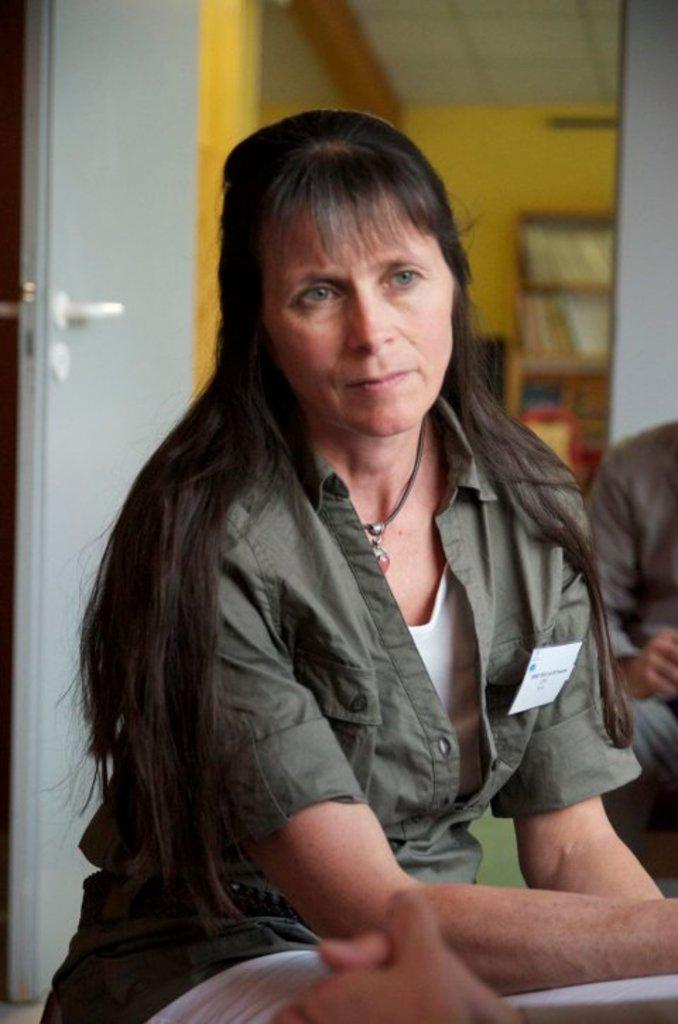Who or what is present in the image? There are people in the image. What can be seen in the background of the image? There are books in the background of the image. How are the books arranged in the image? The books are in racks. What architectural feature is visible in the image? There is a door in the image. What type of fowl can be seen walking around in the image? There is no fowl present in the image. How many dogs are visible in the image? There are no dogs present in the image. 